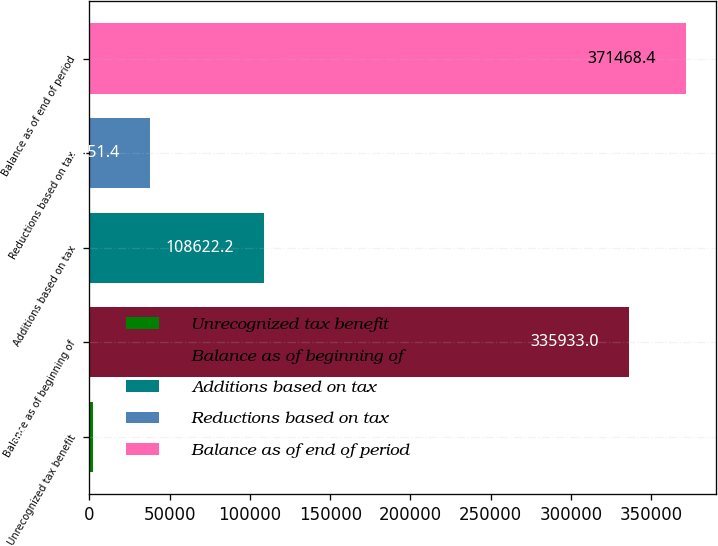Convert chart to OTSL. <chart><loc_0><loc_0><loc_500><loc_500><bar_chart><fcel>Unrecognized tax benefit<fcel>Balance as of beginning of<fcel>Additions based on tax<fcel>Reductions based on tax<fcel>Balance as of end of period<nl><fcel>2016<fcel>335933<fcel>108622<fcel>37551.4<fcel>371468<nl></chart> 